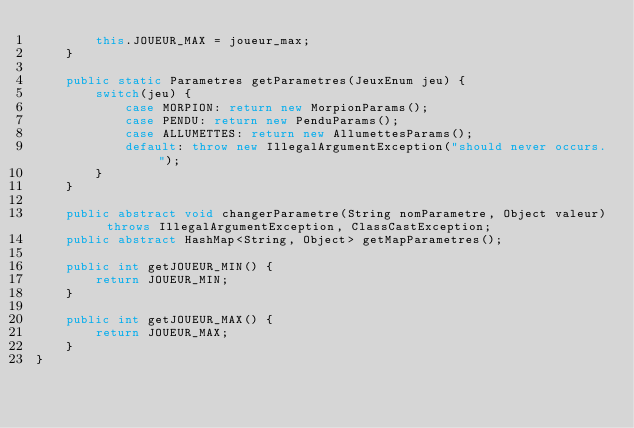Convert code to text. <code><loc_0><loc_0><loc_500><loc_500><_Java_>        this.JOUEUR_MAX = joueur_max;
    }

    public static Parametres getParametres(JeuxEnum jeu) {
        switch(jeu) {
            case MORPION: return new MorpionParams();
            case PENDU: return new PenduParams();
            case ALLUMETTES: return new AllumettesParams();
            default: throw new IllegalArgumentException("should never occurs.");
        }
    }

    public abstract void changerParametre(String nomParametre, Object valeur) throws IllegalArgumentException, ClassCastException;
    public abstract HashMap<String, Object> getMapParametres();

    public int getJOUEUR_MIN() {
        return JOUEUR_MIN;
    }

    public int getJOUEUR_MAX() {
        return JOUEUR_MAX;
    }
}
</code> 